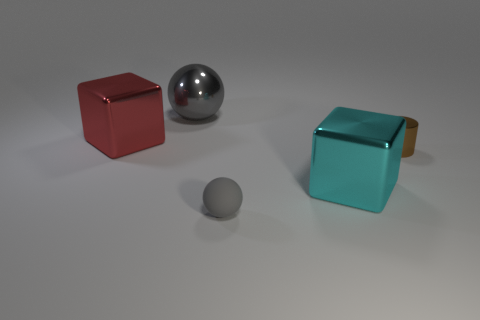Add 1 gray rubber objects. How many objects exist? 6 Subtract 1 spheres. How many spheres are left? 1 Subtract all brown spheres. How many cyan cubes are left? 1 Add 1 big gray metallic spheres. How many big gray metallic spheres are left? 2 Add 2 tiny brown cylinders. How many tiny brown cylinders exist? 3 Subtract 0 yellow spheres. How many objects are left? 5 Subtract all cylinders. How many objects are left? 4 Subtract all gray cubes. Subtract all green balls. How many cubes are left? 2 Subtract all tiny metallic objects. Subtract all purple rubber cylinders. How many objects are left? 4 